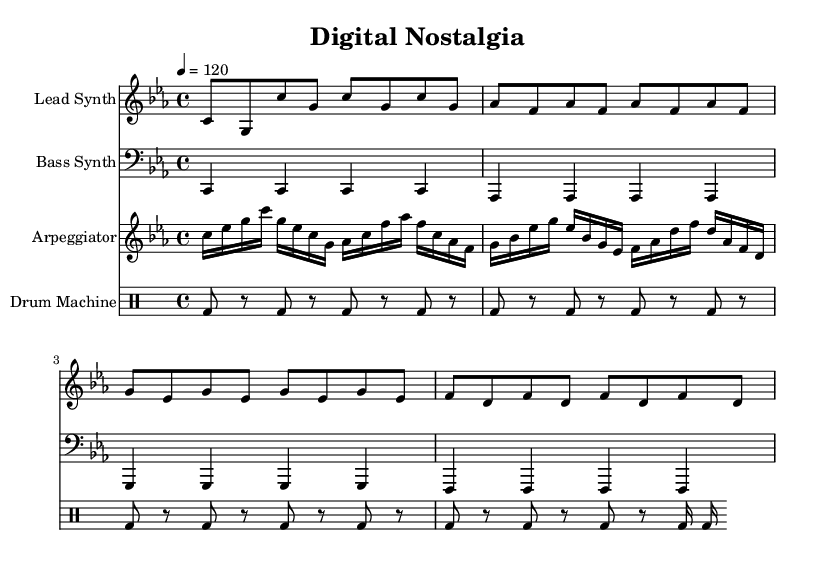what is the key signature of this music? The key signature is C minor, which has three flats (B flat, E flat, and A flat). This can be determined by looking at the key signature indicated at the beginning of the score.
Answer: C minor what is the time signature of this composition? The time signature is 4/4, which is indicated at the beginning of the score. This indicates that there are four beats in each measure and the quarter note gets one beat.
Answer: 4/4 what is the tempo marking for this piece? The tempo marking is 120 beats per minute, specified as “4 = 120” in the score. This indicates the pace at which the music should be played.
Answer: 120 how many measures are in the lead synth part? The lead synth part consists of 8 measures. This can be counted by reviewing the notation, each grouping of notes between bar lines represents a measure.
Answer: 8 which instrument has the longest note value in its part? The bass synth has quarter notes, which are the longest note values in its part since the other parts feature eighth and sixteenth notes. This is evident as each bass note is held for one full beat.
Answer: Bass Synth what rhythmic pattern does the drum machine use in the first four measures? The drum machine uses a consistent kick drum pattern in the first four measures, playing a kick on the first and third beats while resting on the second and fourth, designed for driving a steady dance rhythm.
Answer: Kick on 1 & 3 how does the arpeggiator contribute to the nostalgic feel of the piece? The arpeggiator employs a repetitive pattern across the octave and includes dissonant intervals which is characteristic of synthwave, evoking a sense of technology and nostalgia through its melodic structure and arpeggiated format.
Answer: Evokes nostalgia 